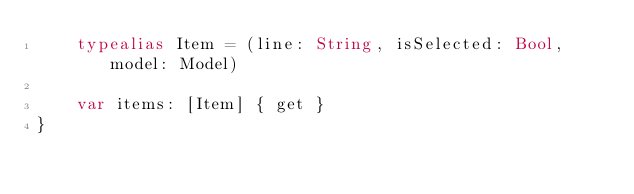<code> <loc_0><loc_0><loc_500><loc_500><_Swift_>    typealias Item = (line: String, isSelected: Bool, model: Model)

    var items: [Item] { get }
}
</code> 